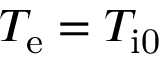<formula> <loc_0><loc_0><loc_500><loc_500>T _ { e } = T _ { i 0 }</formula> 